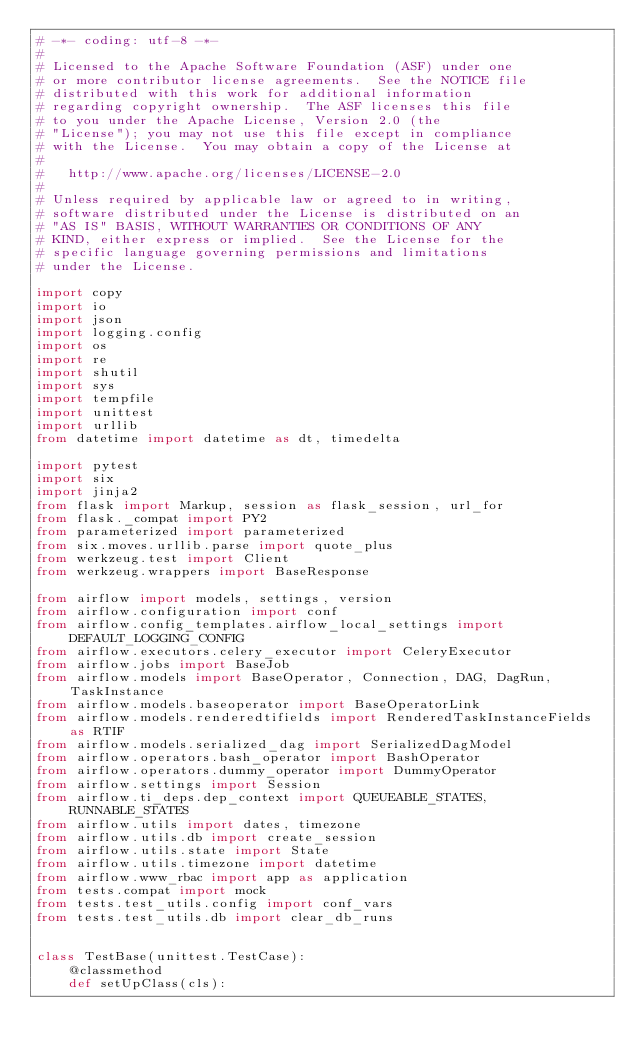<code> <loc_0><loc_0><loc_500><loc_500><_Python_># -*- coding: utf-8 -*-
#
# Licensed to the Apache Software Foundation (ASF) under one
# or more contributor license agreements.  See the NOTICE file
# distributed with this work for additional information
# regarding copyright ownership.  The ASF licenses this file
# to you under the Apache License, Version 2.0 (the
# "License"); you may not use this file except in compliance
# with the License.  You may obtain a copy of the License at
#
#   http://www.apache.org/licenses/LICENSE-2.0
#
# Unless required by applicable law or agreed to in writing,
# software distributed under the License is distributed on an
# "AS IS" BASIS, WITHOUT WARRANTIES OR CONDITIONS OF ANY
# KIND, either express or implied.  See the License for the
# specific language governing permissions and limitations
# under the License.

import copy
import io
import json
import logging.config
import os
import re
import shutil
import sys
import tempfile
import unittest
import urllib
from datetime import datetime as dt, timedelta

import pytest
import six
import jinja2
from flask import Markup, session as flask_session, url_for
from flask._compat import PY2
from parameterized import parameterized
from six.moves.urllib.parse import quote_plus
from werkzeug.test import Client
from werkzeug.wrappers import BaseResponse

from airflow import models, settings, version
from airflow.configuration import conf
from airflow.config_templates.airflow_local_settings import DEFAULT_LOGGING_CONFIG
from airflow.executors.celery_executor import CeleryExecutor
from airflow.jobs import BaseJob
from airflow.models import BaseOperator, Connection, DAG, DagRun, TaskInstance
from airflow.models.baseoperator import BaseOperatorLink
from airflow.models.renderedtifields import RenderedTaskInstanceFields as RTIF
from airflow.models.serialized_dag import SerializedDagModel
from airflow.operators.bash_operator import BashOperator
from airflow.operators.dummy_operator import DummyOperator
from airflow.settings import Session
from airflow.ti_deps.dep_context import QUEUEABLE_STATES, RUNNABLE_STATES
from airflow.utils import dates, timezone
from airflow.utils.db import create_session
from airflow.utils.state import State
from airflow.utils.timezone import datetime
from airflow.www_rbac import app as application
from tests.compat import mock
from tests.test_utils.config import conf_vars
from tests.test_utils.db import clear_db_runs


class TestBase(unittest.TestCase):
    @classmethod
    def setUpClass(cls):</code> 